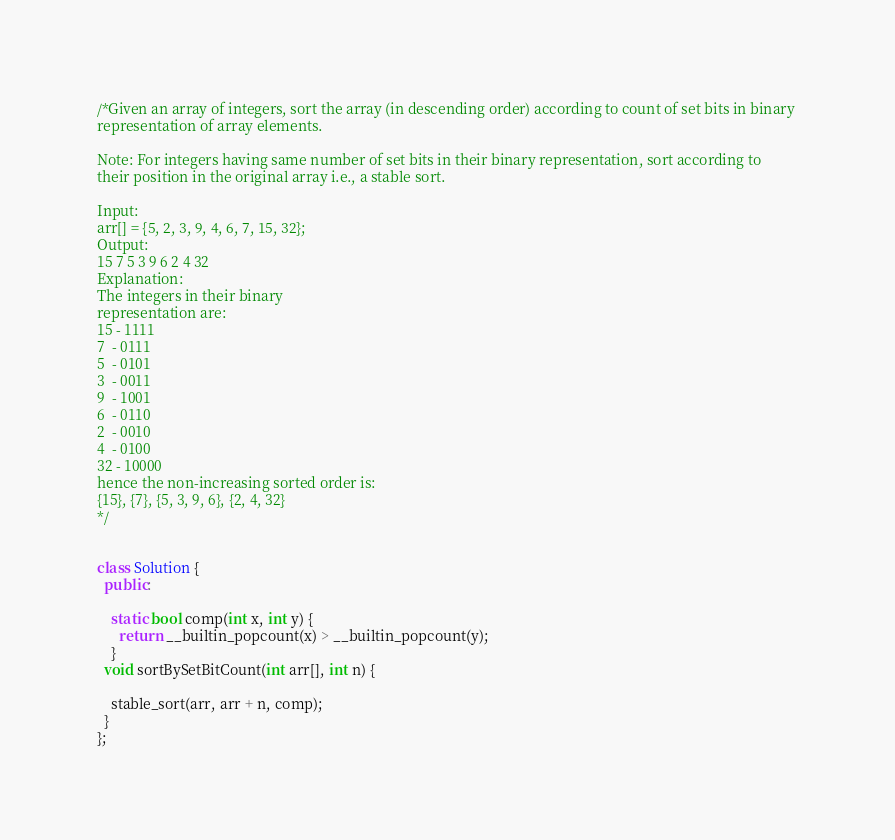Convert code to text. <code><loc_0><loc_0><loc_500><loc_500><_C++_>/*Given an array of integers, sort the array (in descending order) according to count of set bits in binary 
representation of array elements. 

Note: For integers having same number of set bits in their binary representation, sort according to 
their position in the original array i.e., a stable sort.

Input: 
arr[] = {5, 2, 3, 9, 4, 6, 7, 15, 32};
Output:
15 7 5 3 9 6 2 4 32
Explanation:
The integers in their binary
representation are:
15 - 1111
7  - 0111
5  - 0101
3  - 0011
9  - 1001
6  - 0110
2  - 0010
4  - 0100
32 - 10000
hence the non-increasing sorted order is:
{15}, {7}, {5, 3, 9, 6}, {2, 4, 32}
*/


class Solution {
  public:

    static bool comp(int x, int y) {
      return __builtin_popcount(x) > __builtin_popcount(y);
    }
  void sortBySetBitCount(int arr[], int n) {

    stable_sort(arr, arr + n, comp);
  }
};
</code> 